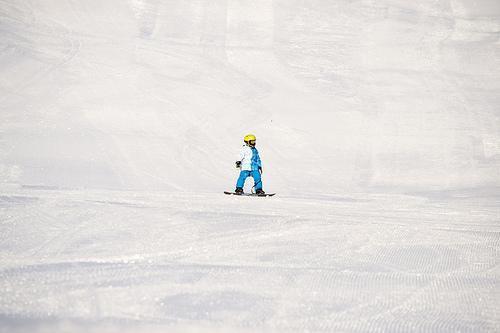How many people in the photo?
Give a very brief answer. 1. 